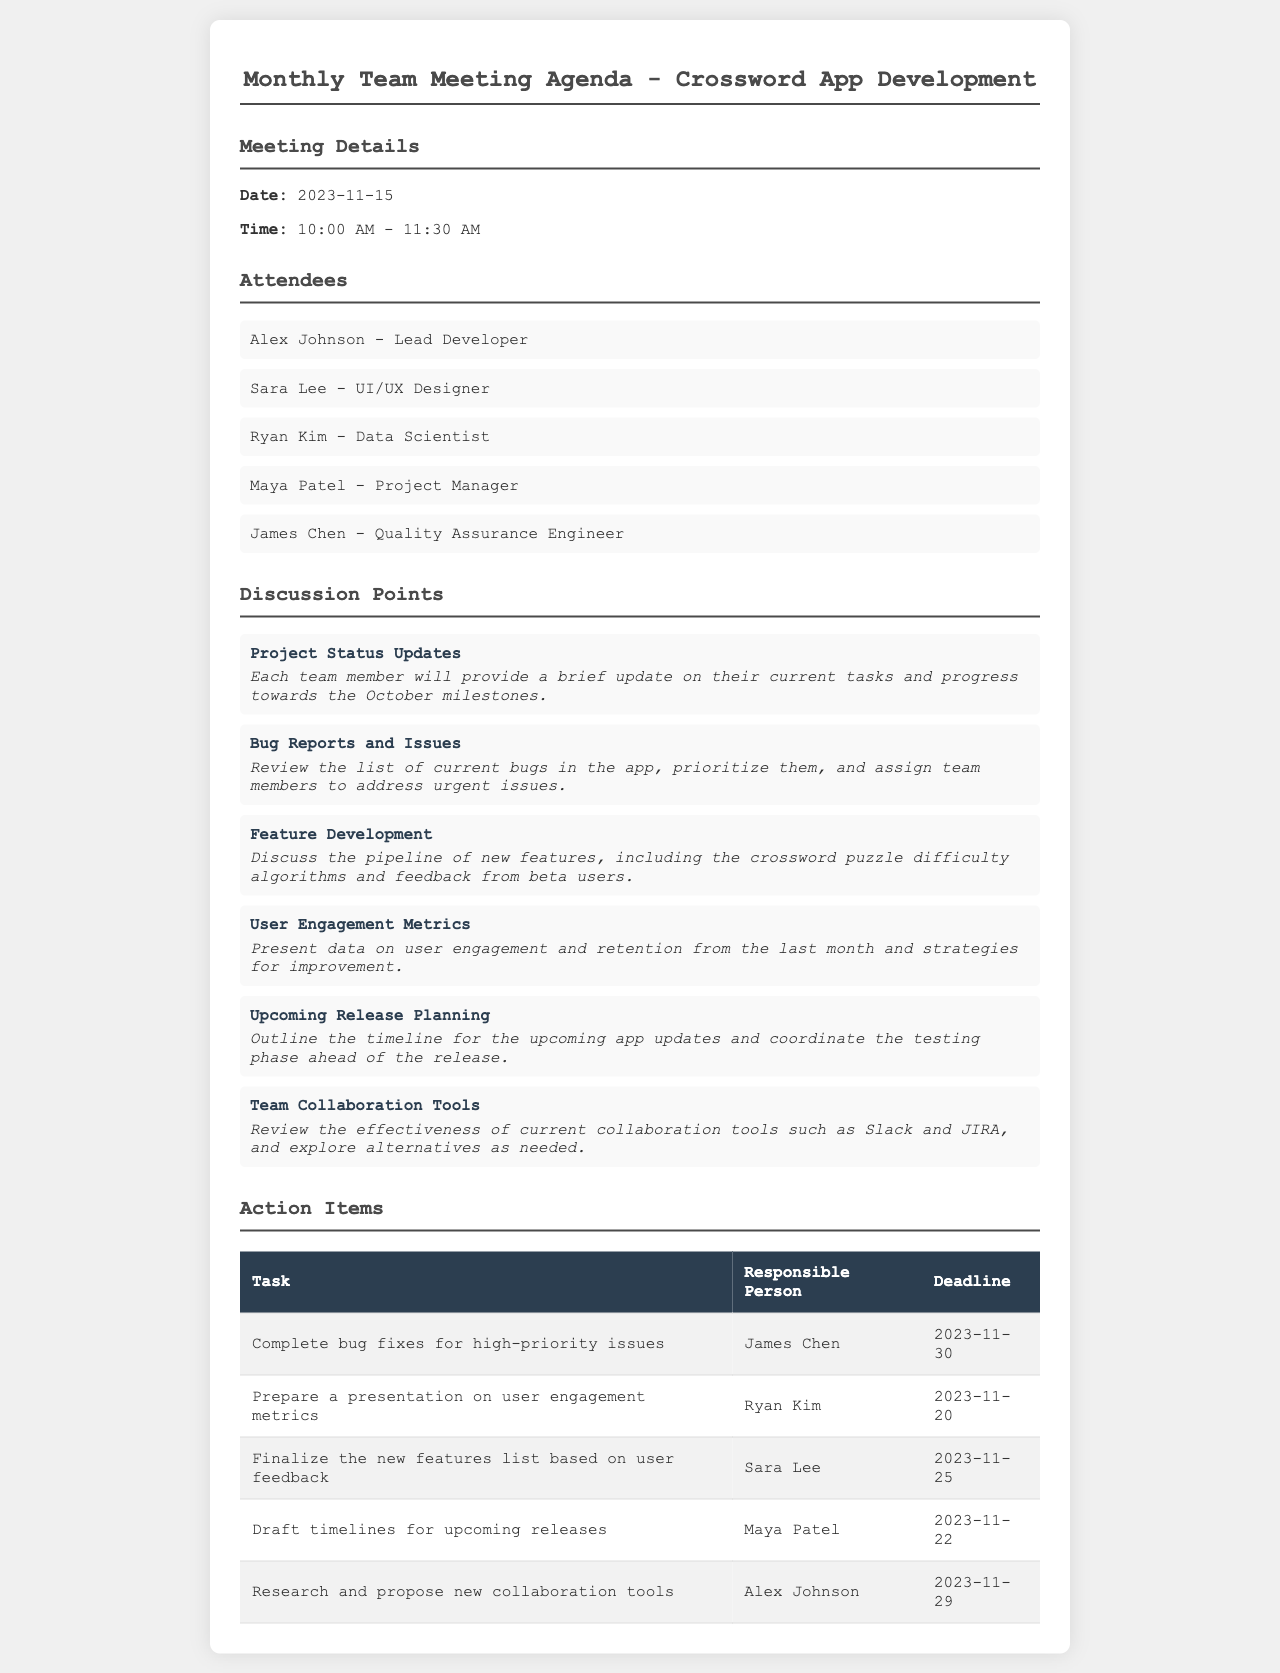what is the meeting date? The date of the meeting is provided under "Meeting Details" in the document.
Answer: 2023-11-15 who is the lead developer? The name of the lead developer is listed under "Attendees" in the document.
Answer: Alex Johnson what time does the meeting start? The starting time of the meeting is mentioned in the "Meeting Details" section.
Answer: 10:00 AM how many discussion points are there? The number of discussion points can be counted from the "Discussion Points" section of the document.
Answer: 6 who is responsible for completing bug fixes? The person assigned to this task is found in the "Action Items" table under the specific task for bug fixes.
Answer: James Chen what is the deadline for preparing the user engagement metrics presentation? This deadline can be found in the "Action Items" table next to the corresponding task.
Answer: 2023-11-20 which tool is reviewed for effectiveness? A specific collaboration tool is mentioned in the "Discussion Points" that will be reviewed.
Answer: Slack what is the title of the document? The title is presented at the top of the document, summarizing its content.
Answer: Monthly Team Meeting Agenda - Crossword App Development 